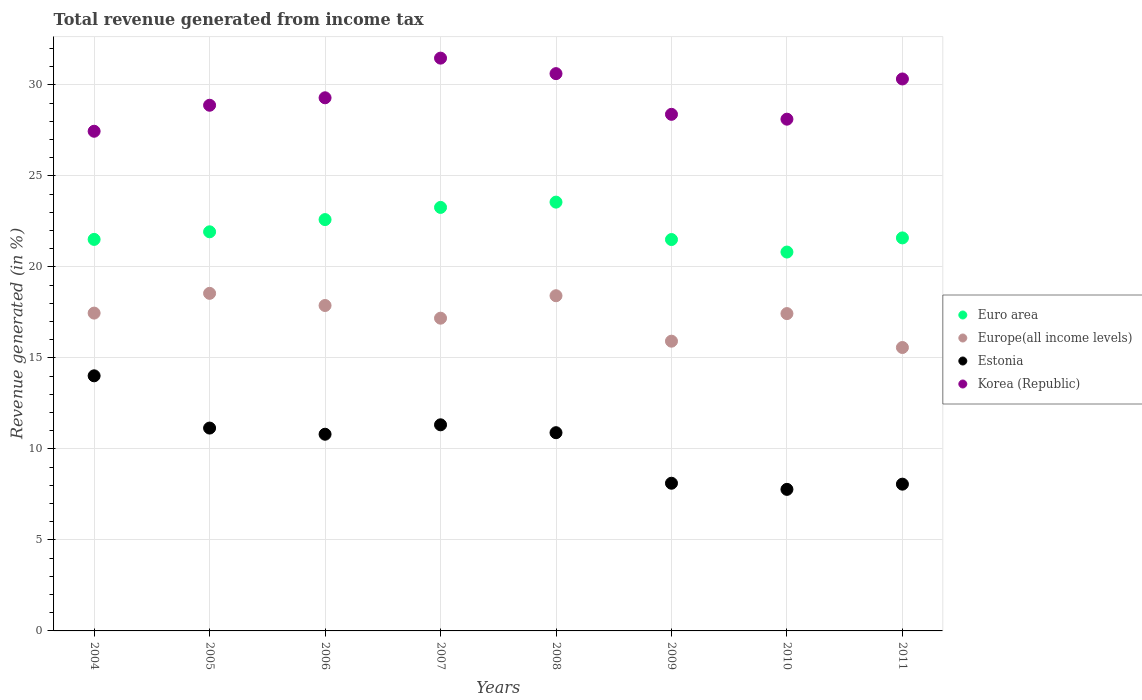How many different coloured dotlines are there?
Ensure brevity in your answer.  4. What is the total revenue generated in Europe(all income levels) in 2009?
Make the answer very short. 15.92. Across all years, what is the maximum total revenue generated in Euro area?
Provide a short and direct response. 23.56. Across all years, what is the minimum total revenue generated in Europe(all income levels)?
Your answer should be very brief. 15.57. What is the total total revenue generated in Euro area in the graph?
Give a very brief answer. 176.78. What is the difference between the total revenue generated in Europe(all income levels) in 2006 and that in 2009?
Offer a terse response. 1.96. What is the difference between the total revenue generated in Korea (Republic) in 2008 and the total revenue generated in Euro area in 2009?
Keep it short and to the point. 9.12. What is the average total revenue generated in Korea (Republic) per year?
Provide a succinct answer. 29.32. In the year 2010, what is the difference between the total revenue generated in Korea (Republic) and total revenue generated in Europe(all income levels)?
Provide a succinct answer. 10.68. What is the ratio of the total revenue generated in Korea (Republic) in 2004 to that in 2006?
Provide a short and direct response. 0.94. Is the difference between the total revenue generated in Korea (Republic) in 2004 and 2006 greater than the difference between the total revenue generated in Europe(all income levels) in 2004 and 2006?
Your answer should be compact. No. What is the difference between the highest and the second highest total revenue generated in Euro area?
Ensure brevity in your answer.  0.29. What is the difference between the highest and the lowest total revenue generated in Euro area?
Offer a very short reply. 2.74. Is it the case that in every year, the sum of the total revenue generated in Euro area and total revenue generated in Korea (Republic)  is greater than the sum of total revenue generated in Estonia and total revenue generated in Europe(all income levels)?
Provide a succinct answer. Yes. How many years are there in the graph?
Provide a short and direct response. 8. Are the values on the major ticks of Y-axis written in scientific E-notation?
Your response must be concise. No. How many legend labels are there?
Ensure brevity in your answer.  4. What is the title of the graph?
Make the answer very short. Total revenue generated from income tax. What is the label or title of the X-axis?
Your response must be concise. Years. What is the label or title of the Y-axis?
Keep it short and to the point. Revenue generated (in %). What is the Revenue generated (in %) in Euro area in 2004?
Offer a very short reply. 21.51. What is the Revenue generated (in %) in Europe(all income levels) in 2004?
Provide a succinct answer. 17.46. What is the Revenue generated (in %) of Estonia in 2004?
Provide a short and direct response. 14.02. What is the Revenue generated (in %) of Korea (Republic) in 2004?
Give a very brief answer. 27.45. What is the Revenue generated (in %) in Euro area in 2005?
Offer a very short reply. 21.93. What is the Revenue generated (in %) in Europe(all income levels) in 2005?
Give a very brief answer. 18.55. What is the Revenue generated (in %) in Estonia in 2005?
Your answer should be compact. 11.15. What is the Revenue generated (in %) in Korea (Republic) in 2005?
Ensure brevity in your answer.  28.88. What is the Revenue generated (in %) in Euro area in 2006?
Ensure brevity in your answer.  22.6. What is the Revenue generated (in %) in Europe(all income levels) in 2006?
Your response must be concise. 17.88. What is the Revenue generated (in %) of Estonia in 2006?
Your response must be concise. 10.81. What is the Revenue generated (in %) of Korea (Republic) in 2006?
Offer a terse response. 29.29. What is the Revenue generated (in %) of Euro area in 2007?
Offer a very short reply. 23.27. What is the Revenue generated (in %) in Europe(all income levels) in 2007?
Offer a very short reply. 17.18. What is the Revenue generated (in %) of Estonia in 2007?
Provide a short and direct response. 11.32. What is the Revenue generated (in %) in Korea (Republic) in 2007?
Ensure brevity in your answer.  31.47. What is the Revenue generated (in %) in Euro area in 2008?
Your answer should be very brief. 23.56. What is the Revenue generated (in %) of Europe(all income levels) in 2008?
Offer a very short reply. 18.42. What is the Revenue generated (in %) of Estonia in 2008?
Give a very brief answer. 10.89. What is the Revenue generated (in %) of Korea (Republic) in 2008?
Give a very brief answer. 30.62. What is the Revenue generated (in %) of Euro area in 2009?
Give a very brief answer. 21.5. What is the Revenue generated (in %) in Europe(all income levels) in 2009?
Give a very brief answer. 15.92. What is the Revenue generated (in %) of Estonia in 2009?
Make the answer very short. 8.11. What is the Revenue generated (in %) in Korea (Republic) in 2009?
Your response must be concise. 28.38. What is the Revenue generated (in %) in Euro area in 2010?
Your response must be concise. 20.82. What is the Revenue generated (in %) in Europe(all income levels) in 2010?
Your response must be concise. 17.44. What is the Revenue generated (in %) in Estonia in 2010?
Your response must be concise. 7.78. What is the Revenue generated (in %) in Korea (Republic) in 2010?
Give a very brief answer. 28.12. What is the Revenue generated (in %) in Euro area in 2011?
Make the answer very short. 21.59. What is the Revenue generated (in %) in Europe(all income levels) in 2011?
Keep it short and to the point. 15.57. What is the Revenue generated (in %) of Estonia in 2011?
Your answer should be compact. 8.06. What is the Revenue generated (in %) in Korea (Republic) in 2011?
Provide a succinct answer. 30.33. Across all years, what is the maximum Revenue generated (in %) in Euro area?
Offer a very short reply. 23.56. Across all years, what is the maximum Revenue generated (in %) in Europe(all income levels)?
Give a very brief answer. 18.55. Across all years, what is the maximum Revenue generated (in %) of Estonia?
Offer a very short reply. 14.02. Across all years, what is the maximum Revenue generated (in %) in Korea (Republic)?
Make the answer very short. 31.47. Across all years, what is the minimum Revenue generated (in %) in Euro area?
Provide a succinct answer. 20.82. Across all years, what is the minimum Revenue generated (in %) in Europe(all income levels)?
Offer a very short reply. 15.57. Across all years, what is the minimum Revenue generated (in %) of Estonia?
Your answer should be compact. 7.78. Across all years, what is the minimum Revenue generated (in %) of Korea (Republic)?
Your response must be concise. 27.45. What is the total Revenue generated (in %) of Euro area in the graph?
Offer a terse response. 176.78. What is the total Revenue generated (in %) of Europe(all income levels) in the graph?
Make the answer very short. 138.42. What is the total Revenue generated (in %) of Estonia in the graph?
Ensure brevity in your answer.  82.14. What is the total Revenue generated (in %) in Korea (Republic) in the graph?
Provide a succinct answer. 234.55. What is the difference between the Revenue generated (in %) of Euro area in 2004 and that in 2005?
Ensure brevity in your answer.  -0.42. What is the difference between the Revenue generated (in %) in Europe(all income levels) in 2004 and that in 2005?
Keep it short and to the point. -1.09. What is the difference between the Revenue generated (in %) of Estonia in 2004 and that in 2005?
Provide a short and direct response. 2.87. What is the difference between the Revenue generated (in %) in Korea (Republic) in 2004 and that in 2005?
Provide a short and direct response. -1.43. What is the difference between the Revenue generated (in %) of Euro area in 2004 and that in 2006?
Keep it short and to the point. -1.09. What is the difference between the Revenue generated (in %) of Europe(all income levels) in 2004 and that in 2006?
Keep it short and to the point. -0.42. What is the difference between the Revenue generated (in %) of Estonia in 2004 and that in 2006?
Your response must be concise. 3.21. What is the difference between the Revenue generated (in %) in Korea (Republic) in 2004 and that in 2006?
Your answer should be compact. -1.84. What is the difference between the Revenue generated (in %) in Euro area in 2004 and that in 2007?
Your answer should be very brief. -1.76. What is the difference between the Revenue generated (in %) in Europe(all income levels) in 2004 and that in 2007?
Provide a succinct answer. 0.28. What is the difference between the Revenue generated (in %) in Estonia in 2004 and that in 2007?
Provide a short and direct response. 2.69. What is the difference between the Revenue generated (in %) of Korea (Republic) in 2004 and that in 2007?
Ensure brevity in your answer.  -4.02. What is the difference between the Revenue generated (in %) in Euro area in 2004 and that in 2008?
Your answer should be compact. -2.05. What is the difference between the Revenue generated (in %) of Europe(all income levels) in 2004 and that in 2008?
Offer a terse response. -0.95. What is the difference between the Revenue generated (in %) in Estonia in 2004 and that in 2008?
Keep it short and to the point. 3.13. What is the difference between the Revenue generated (in %) of Korea (Republic) in 2004 and that in 2008?
Make the answer very short. -3.17. What is the difference between the Revenue generated (in %) in Euro area in 2004 and that in 2009?
Provide a succinct answer. 0.01. What is the difference between the Revenue generated (in %) in Europe(all income levels) in 2004 and that in 2009?
Give a very brief answer. 1.54. What is the difference between the Revenue generated (in %) of Estonia in 2004 and that in 2009?
Provide a short and direct response. 5.9. What is the difference between the Revenue generated (in %) in Korea (Republic) in 2004 and that in 2009?
Your answer should be very brief. -0.93. What is the difference between the Revenue generated (in %) in Euro area in 2004 and that in 2010?
Your answer should be compact. 0.69. What is the difference between the Revenue generated (in %) in Europe(all income levels) in 2004 and that in 2010?
Offer a very short reply. 0.03. What is the difference between the Revenue generated (in %) of Estonia in 2004 and that in 2010?
Your answer should be compact. 6.24. What is the difference between the Revenue generated (in %) of Korea (Republic) in 2004 and that in 2010?
Your answer should be compact. -0.66. What is the difference between the Revenue generated (in %) in Euro area in 2004 and that in 2011?
Ensure brevity in your answer.  -0.08. What is the difference between the Revenue generated (in %) of Europe(all income levels) in 2004 and that in 2011?
Your response must be concise. 1.89. What is the difference between the Revenue generated (in %) of Estonia in 2004 and that in 2011?
Your answer should be compact. 5.95. What is the difference between the Revenue generated (in %) in Korea (Republic) in 2004 and that in 2011?
Make the answer very short. -2.87. What is the difference between the Revenue generated (in %) of Euro area in 2005 and that in 2006?
Keep it short and to the point. -0.67. What is the difference between the Revenue generated (in %) in Europe(all income levels) in 2005 and that in 2006?
Offer a terse response. 0.67. What is the difference between the Revenue generated (in %) of Estonia in 2005 and that in 2006?
Your answer should be compact. 0.34. What is the difference between the Revenue generated (in %) of Korea (Republic) in 2005 and that in 2006?
Give a very brief answer. -0.41. What is the difference between the Revenue generated (in %) in Euro area in 2005 and that in 2007?
Your response must be concise. -1.34. What is the difference between the Revenue generated (in %) in Europe(all income levels) in 2005 and that in 2007?
Your response must be concise. 1.36. What is the difference between the Revenue generated (in %) of Estonia in 2005 and that in 2007?
Your answer should be compact. -0.18. What is the difference between the Revenue generated (in %) of Korea (Republic) in 2005 and that in 2007?
Keep it short and to the point. -2.59. What is the difference between the Revenue generated (in %) of Euro area in 2005 and that in 2008?
Provide a succinct answer. -1.63. What is the difference between the Revenue generated (in %) of Europe(all income levels) in 2005 and that in 2008?
Provide a succinct answer. 0.13. What is the difference between the Revenue generated (in %) of Estonia in 2005 and that in 2008?
Offer a very short reply. 0.25. What is the difference between the Revenue generated (in %) in Korea (Republic) in 2005 and that in 2008?
Offer a very short reply. -1.74. What is the difference between the Revenue generated (in %) of Euro area in 2005 and that in 2009?
Give a very brief answer. 0.42. What is the difference between the Revenue generated (in %) in Europe(all income levels) in 2005 and that in 2009?
Give a very brief answer. 2.63. What is the difference between the Revenue generated (in %) in Estonia in 2005 and that in 2009?
Provide a short and direct response. 3.03. What is the difference between the Revenue generated (in %) in Korea (Republic) in 2005 and that in 2009?
Give a very brief answer. 0.5. What is the difference between the Revenue generated (in %) in Euro area in 2005 and that in 2010?
Ensure brevity in your answer.  1.11. What is the difference between the Revenue generated (in %) in Europe(all income levels) in 2005 and that in 2010?
Offer a very short reply. 1.11. What is the difference between the Revenue generated (in %) of Estonia in 2005 and that in 2010?
Your answer should be compact. 3.37. What is the difference between the Revenue generated (in %) of Korea (Republic) in 2005 and that in 2010?
Offer a very short reply. 0.77. What is the difference between the Revenue generated (in %) of Euro area in 2005 and that in 2011?
Your answer should be very brief. 0.33. What is the difference between the Revenue generated (in %) of Europe(all income levels) in 2005 and that in 2011?
Give a very brief answer. 2.98. What is the difference between the Revenue generated (in %) in Estonia in 2005 and that in 2011?
Your answer should be compact. 3.08. What is the difference between the Revenue generated (in %) of Korea (Republic) in 2005 and that in 2011?
Offer a very short reply. -1.44. What is the difference between the Revenue generated (in %) of Euro area in 2006 and that in 2007?
Offer a very short reply. -0.67. What is the difference between the Revenue generated (in %) in Europe(all income levels) in 2006 and that in 2007?
Your answer should be very brief. 0.7. What is the difference between the Revenue generated (in %) in Estonia in 2006 and that in 2007?
Give a very brief answer. -0.52. What is the difference between the Revenue generated (in %) in Korea (Republic) in 2006 and that in 2007?
Make the answer very short. -2.18. What is the difference between the Revenue generated (in %) of Euro area in 2006 and that in 2008?
Offer a terse response. -0.96. What is the difference between the Revenue generated (in %) of Europe(all income levels) in 2006 and that in 2008?
Keep it short and to the point. -0.54. What is the difference between the Revenue generated (in %) in Estonia in 2006 and that in 2008?
Offer a terse response. -0.08. What is the difference between the Revenue generated (in %) in Korea (Republic) in 2006 and that in 2008?
Provide a short and direct response. -1.33. What is the difference between the Revenue generated (in %) of Euro area in 2006 and that in 2009?
Ensure brevity in your answer.  1.1. What is the difference between the Revenue generated (in %) in Europe(all income levels) in 2006 and that in 2009?
Your response must be concise. 1.96. What is the difference between the Revenue generated (in %) in Estonia in 2006 and that in 2009?
Your answer should be compact. 2.69. What is the difference between the Revenue generated (in %) in Korea (Republic) in 2006 and that in 2009?
Offer a terse response. 0.91. What is the difference between the Revenue generated (in %) of Euro area in 2006 and that in 2010?
Offer a very short reply. 1.78. What is the difference between the Revenue generated (in %) of Europe(all income levels) in 2006 and that in 2010?
Make the answer very short. 0.44. What is the difference between the Revenue generated (in %) in Estonia in 2006 and that in 2010?
Give a very brief answer. 3.03. What is the difference between the Revenue generated (in %) of Korea (Republic) in 2006 and that in 2010?
Provide a succinct answer. 1.17. What is the difference between the Revenue generated (in %) in Euro area in 2006 and that in 2011?
Your answer should be compact. 1.01. What is the difference between the Revenue generated (in %) in Europe(all income levels) in 2006 and that in 2011?
Offer a terse response. 2.31. What is the difference between the Revenue generated (in %) in Estonia in 2006 and that in 2011?
Make the answer very short. 2.74. What is the difference between the Revenue generated (in %) of Korea (Republic) in 2006 and that in 2011?
Offer a terse response. -1.03. What is the difference between the Revenue generated (in %) in Euro area in 2007 and that in 2008?
Keep it short and to the point. -0.29. What is the difference between the Revenue generated (in %) in Europe(all income levels) in 2007 and that in 2008?
Provide a succinct answer. -1.23. What is the difference between the Revenue generated (in %) in Estonia in 2007 and that in 2008?
Your answer should be compact. 0.43. What is the difference between the Revenue generated (in %) of Korea (Republic) in 2007 and that in 2008?
Your answer should be very brief. 0.85. What is the difference between the Revenue generated (in %) in Euro area in 2007 and that in 2009?
Your response must be concise. 1.77. What is the difference between the Revenue generated (in %) of Europe(all income levels) in 2007 and that in 2009?
Keep it short and to the point. 1.26. What is the difference between the Revenue generated (in %) of Estonia in 2007 and that in 2009?
Provide a succinct answer. 3.21. What is the difference between the Revenue generated (in %) of Korea (Republic) in 2007 and that in 2009?
Provide a short and direct response. 3.09. What is the difference between the Revenue generated (in %) in Euro area in 2007 and that in 2010?
Your answer should be very brief. 2.45. What is the difference between the Revenue generated (in %) of Europe(all income levels) in 2007 and that in 2010?
Your response must be concise. -0.25. What is the difference between the Revenue generated (in %) in Estonia in 2007 and that in 2010?
Offer a terse response. 3.55. What is the difference between the Revenue generated (in %) of Korea (Republic) in 2007 and that in 2010?
Your answer should be very brief. 3.35. What is the difference between the Revenue generated (in %) of Euro area in 2007 and that in 2011?
Provide a short and direct response. 1.68. What is the difference between the Revenue generated (in %) of Europe(all income levels) in 2007 and that in 2011?
Provide a succinct answer. 1.61. What is the difference between the Revenue generated (in %) of Estonia in 2007 and that in 2011?
Your answer should be compact. 3.26. What is the difference between the Revenue generated (in %) in Korea (Republic) in 2007 and that in 2011?
Provide a short and direct response. 1.14. What is the difference between the Revenue generated (in %) in Euro area in 2008 and that in 2009?
Your answer should be very brief. 2.06. What is the difference between the Revenue generated (in %) of Europe(all income levels) in 2008 and that in 2009?
Your answer should be very brief. 2.5. What is the difference between the Revenue generated (in %) in Estonia in 2008 and that in 2009?
Your answer should be compact. 2.78. What is the difference between the Revenue generated (in %) in Korea (Republic) in 2008 and that in 2009?
Provide a succinct answer. 2.24. What is the difference between the Revenue generated (in %) of Euro area in 2008 and that in 2010?
Give a very brief answer. 2.74. What is the difference between the Revenue generated (in %) in Europe(all income levels) in 2008 and that in 2010?
Provide a short and direct response. 0.98. What is the difference between the Revenue generated (in %) of Estonia in 2008 and that in 2010?
Provide a short and direct response. 3.11. What is the difference between the Revenue generated (in %) of Korea (Republic) in 2008 and that in 2010?
Ensure brevity in your answer.  2.5. What is the difference between the Revenue generated (in %) of Euro area in 2008 and that in 2011?
Give a very brief answer. 1.97. What is the difference between the Revenue generated (in %) in Europe(all income levels) in 2008 and that in 2011?
Offer a very short reply. 2.84. What is the difference between the Revenue generated (in %) of Estonia in 2008 and that in 2011?
Offer a terse response. 2.83. What is the difference between the Revenue generated (in %) in Korea (Republic) in 2008 and that in 2011?
Provide a succinct answer. 0.29. What is the difference between the Revenue generated (in %) in Euro area in 2009 and that in 2010?
Provide a succinct answer. 0.69. What is the difference between the Revenue generated (in %) in Europe(all income levels) in 2009 and that in 2010?
Provide a succinct answer. -1.52. What is the difference between the Revenue generated (in %) of Estonia in 2009 and that in 2010?
Keep it short and to the point. 0.34. What is the difference between the Revenue generated (in %) in Korea (Republic) in 2009 and that in 2010?
Your answer should be compact. 0.27. What is the difference between the Revenue generated (in %) in Euro area in 2009 and that in 2011?
Give a very brief answer. -0.09. What is the difference between the Revenue generated (in %) of Europe(all income levels) in 2009 and that in 2011?
Provide a succinct answer. 0.35. What is the difference between the Revenue generated (in %) in Estonia in 2009 and that in 2011?
Give a very brief answer. 0.05. What is the difference between the Revenue generated (in %) of Korea (Republic) in 2009 and that in 2011?
Give a very brief answer. -1.94. What is the difference between the Revenue generated (in %) of Euro area in 2010 and that in 2011?
Your answer should be compact. -0.78. What is the difference between the Revenue generated (in %) in Europe(all income levels) in 2010 and that in 2011?
Your answer should be very brief. 1.86. What is the difference between the Revenue generated (in %) in Estonia in 2010 and that in 2011?
Keep it short and to the point. -0.29. What is the difference between the Revenue generated (in %) in Korea (Republic) in 2010 and that in 2011?
Your response must be concise. -2.21. What is the difference between the Revenue generated (in %) in Euro area in 2004 and the Revenue generated (in %) in Europe(all income levels) in 2005?
Give a very brief answer. 2.96. What is the difference between the Revenue generated (in %) of Euro area in 2004 and the Revenue generated (in %) of Estonia in 2005?
Offer a terse response. 10.37. What is the difference between the Revenue generated (in %) in Euro area in 2004 and the Revenue generated (in %) in Korea (Republic) in 2005?
Offer a very short reply. -7.37. What is the difference between the Revenue generated (in %) of Europe(all income levels) in 2004 and the Revenue generated (in %) of Estonia in 2005?
Your answer should be very brief. 6.32. What is the difference between the Revenue generated (in %) of Europe(all income levels) in 2004 and the Revenue generated (in %) of Korea (Republic) in 2005?
Keep it short and to the point. -11.42. What is the difference between the Revenue generated (in %) in Estonia in 2004 and the Revenue generated (in %) in Korea (Republic) in 2005?
Your response must be concise. -14.87. What is the difference between the Revenue generated (in %) of Euro area in 2004 and the Revenue generated (in %) of Europe(all income levels) in 2006?
Ensure brevity in your answer.  3.63. What is the difference between the Revenue generated (in %) in Euro area in 2004 and the Revenue generated (in %) in Estonia in 2006?
Provide a succinct answer. 10.7. What is the difference between the Revenue generated (in %) in Euro area in 2004 and the Revenue generated (in %) in Korea (Republic) in 2006?
Your answer should be very brief. -7.78. What is the difference between the Revenue generated (in %) of Europe(all income levels) in 2004 and the Revenue generated (in %) of Estonia in 2006?
Your answer should be compact. 6.66. What is the difference between the Revenue generated (in %) in Europe(all income levels) in 2004 and the Revenue generated (in %) in Korea (Republic) in 2006?
Provide a succinct answer. -11.83. What is the difference between the Revenue generated (in %) in Estonia in 2004 and the Revenue generated (in %) in Korea (Republic) in 2006?
Give a very brief answer. -15.28. What is the difference between the Revenue generated (in %) in Euro area in 2004 and the Revenue generated (in %) in Europe(all income levels) in 2007?
Your answer should be compact. 4.33. What is the difference between the Revenue generated (in %) of Euro area in 2004 and the Revenue generated (in %) of Estonia in 2007?
Offer a very short reply. 10.19. What is the difference between the Revenue generated (in %) in Euro area in 2004 and the Revenue generated (in %) in Korea (Republic) in 2007?
Make the answer very short. -9.96. What is the difference between the Revenue generated (in %) in Europe(all income levels) in 2004 and the Revenue generated (in %) in Estonia in 2007?
Provide a succinct answer. 6.14. What is the difference between the Revenue generated (in %) in Europe(all income levels) in 2004 and the Revenue generated (in %) in Korea (Republic) in 2007?
Offer a very short reply. -14.01. What is the difference between the Revenue generated (in %) in Estonia in 2004 and the Revenue generated (in %) in Korea (Republic) in 2007?
Your answer should be compact. -17.45. What is the difference between the Revenue generated (in %) in Euro area in 2004 and the Revenue generated (in %) in Europe(all income levels) in 2008?
Ensure brevity in your answer.  3.1. What is the difference between the Revenue generated (in %) of Euro area in 2004 and the Revenue generated (in %) of Estonia in 2008?
Your response must be concise. 10.62. What is the difference between the Revenue generated (in %) of Euro area in 2004 and the Revenue generated (in %) of Korea (Republic) in 2008?
Keep it short and to the point. -9.11. What is the difference between the Revenue generated (in %) in Europe(all income levels) in 2004 and the Revenue generated (in %) in Estonia in 2008?
Ensure brevity in your answer.  6.57. What is the difference between the Revenue generated (in %) in Europe(all income levels) in 2004 and the Revenue generated (in %) in Korea (Republic) in 2008?
Your response must be concise. -13.16. What is the difference between the Revenue generated (in %) in Estonia in 2004 and the Revenue generated (in %) in Korea (Republic) in 2008?
Offer a very short reply. -16.6. What is the difference between the Revenue generated (in %) in Euro area in 2004 and the Revenue generated (in %) in Europe(all income levels) in 2009?
Provide a short and direct response. 5.59. What is the difference between the Revenue generated (in %) in Euro area in 2004 and the Revenue generated (in %) in Estonia in 2009?
Ensure brevity in your answer.  13.4. What is the difference between the Revenue generated (in %) of Euro area in 2004 and the Revenue generated (in %) of Korea (Republic) in 2009?
Offer a terse response. -6.87. What is the difference between the Revenue generated (in %) of Europe(all income levels) in 2004 and the Revenue generated (in %) of Estonia in 2009?
Your response must be concise. 9.35. What is the difference between the Revenue generated (in %) in Europe(all income levels) in 2004 and the Revenue generated (in %) in Korea (Republic) in 2009?
Keep it short and to the point. -10.92. What is the difference between the Revenue generated (in %) of Estonia in 2004 and the Revenue generated (in %) of Korea (Republic) in 2009?
Give a very brief answer. -14.37. What is the difference between the Revenue generated (in %) in Euro area in 2004 and the Revenue generated (in %) in Europe(all income levels) in 2010?
Offer a very short reply. 4.08. What is the difference between the Revenue generated (in %) in Euro area in 2004 and the Revenue generated (in %) in Estonia in 2010?
Offer a terse response. 13.73. What is the difference between the Revenue generated (in %) of Euro area in 2004 and the Revenue generated (in %) of Korea (Republic) in 2010?
Ensure brevity in your answer.  -6.61. What is the difference between the Revenue generated (in %) in Europe(all income levels) in 2004 and the Revenue generated (in %) in Estonia in 2010?
Offer a very short reply. 9.68. What is the difference between the Revenue generated (in %) of Europe(all income levels) in 2004 and the Revenue generated (in %) of Korea (Republic) in 2010?
Provide a succinct answer. -10.65. What is the difference between the Revenue generated (in %) in Estonia in 2004 and the Revenue generated (in %) in Korea (Republic) in 2010?
Your answer should be very brief. -14.1. What is the difference between the Revenue generated (in %) of Euro area in 2004 and the Revenue generated (in %) of Europe(all income levels) in 2011?
Your response must be concise. 5.94. What is the difference between the Revenue generated (in %) in Euro area in 2004 and the Revenue generated (in %) in Estonia in 2011?
Your answer should be very brief. 13.45. What is the difference between the Revenue generated (in %) of Euro area in 2004 and the Revenue generated (in %) of Korea (Republic) in 2011?
Offer a very short reply. -8.82. What is the difference between the Revenue generated (in %) in Europe(all income levels) in 2004 and the Revenue generated (in %) in Estonia in 2011?
Your response must be concise. 9.4. What is the difference between the Revenue generated (in %) of Europe(all income levels) in 2004 and the Revenue generated (in %) of Korea (Republic) in 2011?
Your answer should be compact. -12.86. What is the difference between the Revenue generated (in %) of Estonia in 2004 and the Revenue generated (in %) of Korea (Republic) in 2011?
Keep it short and to the point. -16.31. What is the difference between the Revenue generated (in %) in Euro area in 2005 and the Revenue generated (in %) in Europe(all income levels) in 2006?
Keep it short and to the point. 4.05. What is the difference between the Revenue generated (in %) in Euro area in 2005 and the Revenue generated (in %) in Estonia in 2006?
Offer a terse response. 11.12. What is the difference between the Revenue generated (in %) of Euro area in 2005 and the Revenue generated (in %) of Korea (Republic) in 2006?
Offer a very short reply. -7.36. What is the difference between the Revenue generated (in %) of Europe(all income levels) in 2005 and the Revenue generated (in %) of Estonia in 2006?
Keep it short and to the point. 7.74. What is the difference between the Revenue generated (in %) of Europe(all income levels) in 2005 and the Revenue generated (in %) of Korea (Republic) in 2006?
Your answer should be very brief. -10.74. What is the difference between the Revenue generated (in %) in Estonia in 2005 and the Revenue generated (in %) in Korea (Republic) in 2006?
Offer a very short reply. -18.15. What is the difference between the Revenue generated (in %) of Euro area in 2005 and the Revenue generated (in %) of Europe(all income levels) in 2007?
Provide a succinct answer. 4.75. What is the difference between the Revenue generated (in %) of Euro area in 2005 and the Revenue generated (in %) of Estonia in 2007?
Ensure brevity in your answer.  10.6. What is the difference between the Revenue generated (in %) of Euro area in 2005 and the Revenue generated (in %) of Korea (Republic) in 2007?
Provide a succinct answer. -9.54. What is the difference between the Revenue generated (in %) of Europe(all income levels) in 2005 and the Revenue generated (in %) of Estonia in 2007?
Provide a succinct answer. 7.22. What is the difference between the Revenue generated (in %) in Europe(all income levels) in 2005 and the Revenue generated (in %) in Korea (Republic) in 2007?
Your response must be concise. -12.92. What is the difference between the Revenue generated (in %) in Estonia in 2005 and the Revenue generated (in %) in Korea (Republic) in 2007?
Provide a succinct answer. -20.33. What is the difference between the Revenue generated (in %) of Euro area in 2005 and the Revenue generated (in %) of Europe(all income levels) in 2008?
Your response must be concise. 3.51. What is the difference between the Revenue generated (in %) of Euro area in 2005 and the Revenue generated (in %) of Estonia in 2008?
Offer a very short reply. 11.04. What is the difference between the Revenue generated (in %) in Euro area in 2005 and the Revenue generated (in %) in Korea (Republic) in 2008?
Keep it short and to the point. -8.69. What is the difference between the Revenue generated (in %) of Europe(all income levels) in 2005 and the Revenue generated (in %) of Estonia in 2008?
Keep it short and to the point. 7.66. What is the difference between the Revenue generated (in %) in Europe(all income levels) in 2005 and the Revenue generated (in %) in Korea (Republic) in 2008?
Your response must be concise. -12.07. What is the difference between the Revenue generated (in %) of Estonia in 2005 and the Revenue generated (in %) of Korea (Republic) in 2008?
Provide a succinct answer. -19.47. What is the difference between the Revenue generated (in %) in Euro area in 2005 and the Revenue generated (in %) in Europe(all income levels) in 2009?
Give a very brief answer. 6.01. What is the difference between the Revenue generated (in %) of Euro area in 2005 and the Revenue generated (in %) of Estonia in 2009?
Your response must be concise. 13.81. What is the difference between the Revenue generated (in %) in Euro area in 2005 and the Revenue generated (in %) in Korea (Republic) in 2009?
Your response must be concise. -6.45. What is the difference between the Revenue generated (in %) in Europe(all income levels) in 2005 and the Revenue generated (in %) in Estonia in 2009?
Provide a succinct answer. 10.43. What is the difference between the Revenue generated (in %) in Europe(all income levels) in 2005 and the Revenue generated (in %) in Korea (Republic) in 2009?
Provide a succinct answer. -9.84. What is the difference between the Revenue generated (in %) of Estonia in 2005 and the Revenue generated (in %) of Korea (Republic) in 2009?
Ensure brevity in your answer.  -17.24. What is the difference between the Revenue generated (in %) of Euro area in 2005 and the Revenue generated (in %) of Europe(all income levels) in 2010?
Provide a succinct answer. 4.49. What is the difference between the Revenue generated (in %) in Euro area in 2005 and the Revenue generated (in %) in Estonia in 2010?
Keep it short and to the point. 14.15. What is the difference between the Revenue generated (in %) of Euro area in 2005 and the Revenue generated (in %) of Korea (Republic) in 2010?
Ensure brevity in your answer.  -6.19. What is the difference between the Revenue generated (in %) in Europe(all income levels) in 2005 and the Revenue generated (in %) in Estonia in 2010?
Make the answer very short. 10.77. What is the difference between the Revenue generated (in %) in Europe(all income levels) in 2005 and the Revenue generated (in %) in Korea (Republic) in 2010?
Your response must be concise. -9.57. What is the difference between the Revenue generated (in %) in Estonia in 2005 and the Revenue generated (in %) in Korea (Republic) in 2010?
Offer a very short reply. -16.97. What is the difference between the Revenue generated (in %) of Euro area in 2005 and the Revenue generated (in %) of Europe(all income levels) in 2011?
Provide a succinct answer. 6.36. What is the difference between the Revenue generated (in %) of Euro area in 2005 and the Revenue generated (in %) of Estonia in 2011?
Your response must be concise. 13.86. What is the difference between the Revenue generated (in %) of Euro area in 2005 and the Revenue generated (in %) of Korea (Republic) in 2011?
Keep it short and to the point. -8.4. What is the difference between the Revenue generated (in %) in Europe(all income levels) in 2005 and the Revenue generated (in %) in Estonia in 2011?
Make the answer very short. 10.48. What is the difference between the Revenue generated (in %) of Europe(all income levels) in 2005 and the Revenue generated (in %) of Korea (Republic) in 2011?
Make the answer very short. -11.78. What is the difference between the Revenue generated (in %) in Estonia in 2005 and the Revenue generated (in %) in Korea (Republic) in 2011?
Keep it short and to the point. -19.18. What is the difference between the Revenue generated (in %) of Euro area in 2006 and the Revenue generated (in %) of Europe(all income levels) in 2007?
Your response must be concise. 5.42. What is the difference between the Revenue generated (in %) in Euro area in 2006 and the Revenue generated (in %) in Estonia in 2007?
Make the answer very short. 11.28. What is the difference between the Revenue generated (in %) in Euro area in 2006 and the Revenue generated (in %) in Korea (Republic) in 2007?
Offer a very short reply. -8.87. What is the difference between the Revenue generated (in %) in Europe(all income levels) in 2006 and the Revenue generated (in %) in Estonia in 2007?
Provide a succinct answer. 6.56. What is the difference between the Revenue generated (in %) of Europe(all income levels) in 2006 and the Revenue generated (in %) of Korea (Republic) in 2007?
Provide a short and direct response. -13.59. What is the difference between the Revenue generated (in %) in Estonia in 2006 and the Revenue generated (in %) in Korea (Republic) in 2007?
Your answer should be compact. -20.66. What is the difference between the Revenue generated (in %) in Euro area in 2006 and the Revenue generated (in %) in Europe(all income levels) in 2008?
Give a very brief answer. 4.18. What is the difference between the Revenue generated (in %) of Euro area in 2006 and the Revenue generated (in %) of Estonia in 2008?
Ensure brevity in your answer.  11.71. What is the difference between the Revenue generated (in %) in Euro area in 2006 and the Revenue generated (in %) in Korea (Republic) in 2008?
Ensure brevity in your answer.  -8.02. What is the difference between the Revenue generated (in %) in Europe(all income levels) in 2006 and the Revenue generated (in %) in Estonia in 2008?
Offer a terse response. 6.99. What is the difference between the Revenue generated (in %) in Europe(all income levels) in 2006 and the Revenue generated (in %) in Korea (Republic) in 2008?
Give a very brief answer. -12.74. What is the difference between the Revenue generated (in %) of Estonia in 2006 and the Revenue generated (in %) of Korea (Republic) in 2008?
Ensure brevity in your answer.  -19.81. What is the difference between the Revenue generated (in %) in Euro area in 2006 and the Revenue generated (in %) in Europe(all income levels) in 2009?
Ensure brevity in your answer.  6.68. What is the difference between the Revenue generated (in %) in Euro area in 2006 and the Revenue generated (in %) in Estonia in 2009?
Make the answer very short. 14.49. What is the difference between the Revenue generated (in %) in Euro area in 2006 and the Revenue generated (in %) in Korea (Republic) in 2009?
Your response must be concise. -5.78. What is the difference between the Revenue generated (in %) in Europe(all income levels) in 2006 and the Revenue generated (in %) in Estonia in 2009?
Offer a very short reply. 9.77. What is the difference between the Revenue generated (in %) of Europe(all income levels) in 2006 and the Revenue generated (in %) of Korea (Republic) in 2009?
Give a very brief answer. -10.5. What is the difference between the Revenue generated (in %) in Estonia in 2006 and the Revenue generated (in %) in Korea (Republic) in 2009?
Your answer should be very brief. -17.58. What is the difference between the Revenue generated (in %) of Euro area in 2006 and the Revenue generated (in %) of Europe(all income levels) in 2010?
Give a very brief answer. 5.16. What is the difference between the Revenue generated (in %) in Euro area in 2006 and the Revenue generated (in %) in Estonia in 2010?
Your answer should be compact. 14.82. What is the difference between the Revenue generated (in %) of Euro area in 2006 and the Revenue generated (in %) of Korea (Republic) in 2010?
Your response must be concise. -5.52. What is the difference between the Revenue generated (in %) in Europe(all income levels) in 2006 and the Revenue generated (in %) in Estonia in 2010?
Your answer should be very brief. 10.1. What is the difference between the Revenue generated (in %) of Europe(all income levels) in 2006 and the Revenue generated (in %) of Korea (Republic) in 2010?
Offer a very short reply. -10.24. What is the difference between the Revenue generated (in %) of Estonia in 2006 and the Revenue generated (in %) of Korea (Republic) in 2010?
Keep it short and to the point. -17.31. What is the difference between the Revenue generated (in %) in Euro area in 2006 and the Revenue generated (in %) in Europe(all income levels) in 2011?
Make the answer very short. 7.03. What is the difference between the Revenue generated (in %) of Euro area in 2006 and the Revenue generated (in %) of Estonia in 2011?
Provide a succinct answer. 14.54. What is the difference between the Revenue generated (in %) of Euro area in 2006 and the Revenue generated (in %) of Korea (Republic) in 2011?
Provide a succinct answer. -7.73. What is the difference between the Revenue generated (in %) of Europe(all income levels) in 2006 and the Revenue generated (in %) of Estonia in 2011?
Offer a very short reply. 9.82. What is the difference between the Revenue generated (in %) in Europe(all income levels) in 2006 and the Revenue generated (in %) in Korea (Republic) in 2011?
Offer a very short reply. -12.45. What is the difference between the Revenue generated (in %) of Estonia in 2006 and the Revenue generated (in %) of Korea (Republic) in 2011?
Your answer should be compact. -19.52. What is the difference between the Revenue generated (in %) in Euro area in 2007 and the Revenue generated (in %) in Europe(all income levels) in 2008?
Your response must be concise. 4.85. What is the difference between the Revenue generated (in %) in Euro area in 2007 and the Revenue generated (in %) in Estonia in 2008?
Provide a short and direct response. 12.38. What is the difference between the Revenue generated (in %) in Euro area in 2007 and the Revenue generated (in %) in Korea (Republic) in 2008?
Give a very brief answer. -7.35. What is the difference between the Revenue generated (in %) of Europe(all income levels) in 2007 and the Revenue generated (in %) of Estonia in 2008?
Offer a very short reply. 6.29. What is the difference between the Revenue generated (in %) of Europe(all income levels) in 2007 and the Revenue generated (in %) of Korea (Republic) in 2008?
Give a very brief answer. -13.44. What is the difference between the Revenue generated (in %) in Estonia in 2007 and the Revenue generated (in %) in Korea (Republic) in 2008?
Provide a short and direct response. -19.29. What is the difference between the Revenue generated (in %) of Euro area in 2007 and the Revenue generated (in %) of Europe(all income levels) in 2009?
Offer a very short reply. 7.35. What is the difference between the Revenue generated (in %) in Euro area in 2007 and the Revenue generated (in %) in Estonia in 2009?
Offer a very short reply. 15.15. What is the difference between the Revenue generated (in %) in Euro area in 2007 and the Revenue generated (in %) in Korea (Republic) in 2009?
Your answer should be very brief. -5.11. What is the difference between the Revenue generated (in %) in Europe(all income levels) in 2007 and the Revenue generated (in %) in Estonia in 2009?
Your answer should be compact. 9.07. What is the difference between the Revenue generated (in %) of Europe(all income levels) in 2007 and the Revenue generated (in %) of Korea (Republic) in 2009?
Ensure brevity in your answer.  -11.2. What is the difference between the Revenue generated (in %) of Estonia in 2007 and the Revenue generated (in %) of Korea (Republic) in 2009?
Provide a short and direct response. -17.06. What is the difference between the Revenue generated (in %) of Euro area in 2007 and the Revenue generated (in %) of Europe(all income levels) in 2010?
Your answer should be compact. 5.83. What is the difference between the Revenue generated (in %) in Euro area in 2007 and the Revenue generated (in %) in Estonia in 2010?
Give a very brief answer. 15.49. What is the difference between the Revenue generated (in %) in Euro area in 2007 and the Revenue generated (in %) in Korea (Republic) in 2010?
Provide a short and direct response. -4.85. What is the difference between the Revenue generated (in %) of Europe(all income levels) in 2007 and the Revenue generated (in %) of Estonia in 2010?
Make the answer very short. 9.41. What is the difference between the Revenue generated (in %) in Europe(all income levels) in 2007 and the Revenue generated (in %) in Korea (Republic) in 2010?
Offer a very short reply. -10.93. What is the difference between the Revenue generated (in %) in Estonia in 2007 and the Revenue generated (in %) in Korea (Republic) in 2010?
Provide a succinct answer. -16.79. What is the difference between the Revenue generated (in %) of Euro area in 2007 and the Revenue generated (in %) of Europe(all income levels) in 2011?
Your answer should be very brief. 7.7. What is the difference between the Revenue generated (in %) of Euro area in 2007 and the Revenue generated (in %) of Estonia in 2011?
Offer a very short reply. 15.21. What is the difference between the Revenue generated (in %) of Euro area in 2007 and the Revenue generated (in %) of Korea (Republic) in 2011?
Your answer should be very brief. -7.06. What is the difference between the Revenue generated (in %) in Europe(all income levels) in 2007 and the Revenue generated (in %) in Estonia in 2011?
Provide a succinct answer. 9.12. What is the difference between the Revenue generated (in %) in Europe(all income levels) in 2007 and the Revenue generated (in %) in Korea (Republic) in 2011?
Provide a short and direct response. -13.14. What is the difference between the Revenue generated (in %) in Estonia in 2007 and the Revenue generated (in %) in Korea (Republic) in 2011?
Provide a short and direct response. -19. What is the difference between the Revenue generated (in %) of Euro area in 2008 and the Revenue generated (in %) of Europe(all income levels) in 2009?
Keep it short and to the point. 7.64. What is the difference between the Revenue generated (in %) of Euro area in 2008 and the Revenue generated (in %) of Estonia in 2009?
Your response must be concise. 15.45. What is the difference between the Revenue generated (in %) of Euro area in 2008 and the Revenue generated (in %) of Korea (Republic) in 2009?
Your answer should be compact. -4.82. What is the difference between the Revenue generated (in %) in Europe(all income levels) in 2008 and the Revenue generated (in %) in Estonia in 2009?
Your answer should be very brief. 10.3. What is the difference between the Revenue generated (in %) in Europe(all income levels) in 2008 and the Revenue generated (in %) in Korea (Republic) in 2009?
Give a very brief answer. -9.97. What is the difference between the Revenue generated (in %) in Estonia in 2008 and the Revenue generated (in %) in Korea (Republic) in 2009?
Provide a short and direct response. -17.49. What is the difference between the Revenue generated (in %) of Euro area in 2008 and the Revenue generated (in %) of Europe(all income levels) in 2010?
Your answer should be compact. 6.12. What is the difference between the Revenue generated (in %) in Euro area in 2008 and the Revenue generated (in %) in Estonia in 2010?
Provide a short and direct response. 15.78. What is the difference between the Revenue generated (in %) of Euro area in 2008 and the Revenue generated (in %) of Korea (Republic) in 2010?
Your answer should be compact. -4.56. What is the difference between the Revenue generated (in %) in Europe(all income levels) in 2008 and the Revenue generated (in %) in Estonia in 2010?
Provide a short and direct response. 10.64. What is the difference between the Revenue generated (in %) of Europe(all income levels) in 2008 and the Revenue generated (in %) of Korea (Republic) in 2010?
Offer a very short reply. -9.7. What is the difference between the Revenue generated (in %) of Estonia in 2008 and the Revenue generated (in %) of Korea (Republic) in 2010?
Offer a very short reply. -17.23. What is the difference between the Revenue generated (in %) in Euro area in 2008 and the Revenue generated (in %) in Europe(all income levels) in 2011?
Your answer should be very brief. 7.99. What is the difference between the Revenue generated (in %) of Euro area in 2008 and the Revenue generated (in %) of Estonia in 2011?
Make the answer very short. 15.5. What is the difference between the Revenue generated (in %) of Euro area in 2008 and the Revenue generated (in %) of Korea (Republic) in 2011?
Your response must be concise. -6.77. What is the difference between the Revenue generated (in %) in Europe(all income levels) in 2008 and the Revenue generated (in %) in Estonia in 2011?
Provide a short and direct response. 10.35. What is the difference between the Revenue generated (in %) in Europe(all income levels) in 2008 and the Revenue generated (in %) in Korea (Republic) in 2011?
Provide a succinct answer. -11.91. What is the difference between the Revenue generated (in %) in Estonia in 2008 and the Revenue generated (in %) in Korea (Republic) in 2011?
Ensure brevity in your answer.  -19.44. What is the difference between the Revenue generated (in %) in Euro area in 2009 and the Revenue generated (in %) in Europe(all income levels) in 2010?
Provide a succinct answer. 4.07. What is the difference between the Revenue generated (in %) of Euro area in 2009 and the Revenue generated (in %) of Estonia in 2010?
Offer a very short reply. 13.73. What is the difference between the Revenue generated (in %) in Euro area in 2009 and the Revenue generated (in %) in Korea (Republic) in 2010?
Offer a terse response. -6.61. What is the difference between the Revenue generated (in %) in Europe(all income levels) in 2009 and the Revenue generated (in %) in Estonia in 2010?
Offer a terse response. 8.14. What is the difference between the Revenue generated (in %) in Europe(all income levels) in 2009 and the Revenue generated (in %) in Korea (Republic) in 2010?
Make the answer very short. -12.2. What is the difference between the Revenue generated (in %) of Estonia in 2009 and the Revenue generated (in %) of Korea (Republic) in 2010?
Your answer should be very brief. -20. What is the difference between the Revenue generated (in %) in Euro area in 2009 and the Revenue generated (in %) in Europe(all income levels) in 2011?
Keep it short and to the point. 5.93. What is the difference between the Revenue generated (in %) of Euro area in 2009 and the Revenue generated (in %) of Estonia in 2011?
Your answer should be very brief. 13.44. What is the difference between the Revenue generated (in %) of Euro area in 2009 and the Revenue generated (in %) of Korea (Republic) in 2011?
Your answer should be very brief. -8.82. What is the difference between the Revenue generated (in %) of Europe(all income levels) in 2009 and the Revenue generated (in %) of Estonia in 2011?
Give a very brief answer. 7.86. What is the difference between the Revenue generated (in %) of Europe(all income levels) in 2009 and the Revenue generated (in %) of Korea (Republic) in 2011?
Your response must be concise. -14.41. What is the difference between the Revenue generated (in %) in Estonia in 2009 and the Revenue generated (in %) in Korea (Republic) in 2011?
Your answer should be very brief. -22.21. What is the difference between the Revenue generated (in %) of Euro area in 2010 and the Revenue generated (in %) of Europe(all income levels) in 2011?
Your answer should be compact. 5.24. What is the difference between the Revenue generated (in %) of Euro area in 2010 and the Revenue generated (in %) of Estonia in 2011?
Provide a succinct answer. 12.75. What is the difference between the Revenue generated (in %) of Euro area in 2010 and the Revenue generated (in %) of Korea (Republic) in 2011?
Ensure brevity in your answer.  -9.51. What is the difference between the Revenue generated (in %) of Europe(all income levels) in 2010 and the Revenue generated (in %) of Estonia in 2011?
Make the answer very short. 9.37. What is the difference between the Revenue generated (in %) of Europe(all income levels) in 2010 and the Revenue generated (in %) of Korea (Republic) in 2011?
Your answer should be very brief. -12.89. What is the difference between the Revenue generated (in %) of Estonia in 2010 and the Revenue generated (in %) of Korea (Republic) in 2011?
Your answer should be compact. -22.55. What is the average Revenue generated (in %) of Euro area per year?
Make the answer very short. 22.1. What is the average Revenue generated (in %) of Europe(all income levels) per year?
Provide a short and direct response. 17.3. What is the average Revenue generated (in %) in Estonia per year?
Your answer should be compact. 10.27. What is the average Revenue generated (in %) of Korea (Republic) per year?
Make the answer very short. 29.32. In the year 2004, what is the difference between the Revenue generated (in %) of Euro area and Revenue generated (in %) of Europe(all income levels)?
Provide a succinct answer. 4.05. In the year 2004, what is the difference between the Revenue generated (in %) in Euro area and Revenue generated (in %) in Estonia?
Keep it short and to the point. 7.5. In the year 2004, what is the difference between the Revenue generated (in %) in Euro area and Revenue generated (in %) in Korea (Republic)?
Make the answer very short. -5.94. In the year 2004, what is the difference between the Revenue generated (in %) of Europe(all income levels) and Revenue generated (in %) of Estonia?
Keep it short and to the point. 3.45. In the year 2004, what is the difference between the Revenue generated (in %) of Europe(all income levels) and Revenue generated (in %) of Korea (Republic)?
Offer a terse response. -9.99. In the year 2004, what is the difference between the Revenue generated (in %) in Estonia and Revenue generated (in %) in Korea (Republic)?
Offer a very short reply. -13.44. In the year 2005, what is the difference between the Revenue generated (in %) in Euro area and Revenue generated (in %) in Europe(all income levels)?
Provide a short and direct response. 3.38. In the year 2005, what is the difference between the Revenue generated (in %) of Euro area and Revenue generated (in %) of Estonia?
Give a very brief answer. 10.78. In the year 2005, what is the difference between the Revenue generated (in %) in Euro area and Revenue generated (in %) in Korea (Republic)?
Keep it short and to the point. -6.95. In the year 2005, what is the difference between the Revenue generated (in %) of Europe(all income levels) and Revenue generated (in %) of Estonia?
Your answer should be very brief. 7.4. In the year 2005, what is the difference between the Revenue generated (in %) of Europe(all income levels) and Revenue generated (in %) of Korea (Republic)?
Provide a short and direct response. -10.33. In the year 2005, what is the difference between the Revenue generated (in %) in Estonia and Revenue generated (in %) in Korea (Republic)?
Offer a very short reply. -17.74. In the year 2006, what is the difference between the Revenue generated (in %) of Euro area and Revenue generated (in %) of Europe(all income levels)?
Provide a short and direct response. 4.72. In the year 2006, what is the difference between the Revenue generated (in %) of Euro area and Revenue generated (in %) of Estonia?
Provide a succinct answer. 11.79. In the year 2006, what is the difference between the Revenue generated (in %) of Euro area and Revenue generated (in %) of Korea (Republic)?
Ensure brevity in your answer.  -6.69. In the year 2006, what is the difference between the Revenue generated (in %) in Europe(all income levels) and Revenue generated (in %) in Estonia?
Offer a terse response. 7.07. In the year 2006, what is the difference between the Revenue generated (in %) in Europe(all income levels) and Revenue generated (in %) in Korea (Republic)?
Your response must be concise. -11.41. In the year 2006, what is the difference between the Revenue generated (in %) in Estonia and Revenue generated (in %) in Korea (Republic)?
Provide a short and direct response. -18.49. In the year 2007, what is the difference between the Revenue generated (in %) of Euro area and Revenue generated (in %) of Europe(all income levels)?
Offer a terse response. 6.09. In the year 2007, what is the difference between the Revenue generated (in %) of Euro area and Revenue generated (in %) of Estonia?
Provide a succinct answer. 11.94. In the year 2007, what is the difference between the Revenue generated (in %) in Euro area and Revenue generated (in %) in Korea (Republic)?
Make the answer very short. -8.2. In the year 2007, what is the difference between the Revenue generated (in %) of Europe(all income levels) and Revenue generated (in %) of Estonia?
Your answer should be very brief. 5.86. In the year 2007, what is the difference between the Revenue generated (in %) in Europe(all income levels) and Revenue generated (in %) in Korea (Republic)?
Provide a succinct answer. -14.29. In the year 2007, what is the difference between the Revenue generated (in %) in Estonia and Revenue generated (in %) in Korea (Republic)?
Your response must be concise. -20.15. In the year 2008, what is the difference between the Revenue generated (in %) of Euro area and Revenue generated (in %) of Europe(all income levels)?
Provide a short and direct response. 5.14. In the year 2008, what is the difference between the Revenue generated (in %) of Euro area and Revenue generated (in %) of Estonia?
Your response must be concise. 12.67. In the year 2008, what is the difference between the Revenue generated (in %) in Euro area and Revenue generated (in %) in Korea (Republic)?
Ensure brevity in your answer.  -7.06. In the year 2008, what is the difference between the Revenue generated (in %) of Europe(all income levels) and Revenue generated (in %) of Estonia?
Provide a succinct answer. 7.53. In the year 2008, what is the difference between the Revenue generated (in %) in Europe(all income levels) and Revenue generated (in %) in Korea (Republic)?
Provide a succinct answer. -12.2. In the year 2008, what is the difference between the Revenue generated (in %) in Estonia and Revenue generated (in %) in Korea (Republic)?
Ensure brevity in your answer.  -19.73. In the year 2009, what is the difference between the Revenue generated (in %) in Euro area and Revenue generated (in %) in Europe(all income levels)?
Give a very brief answer. 5.58. In the year 2009, what is the difference between the Revenue generated (in %) of Euro area and Revenue generated (in %) of Estonia?
Your answer should be compact. 13.39. In the year 2009, what is the difference between the Revenue generated (in %) in Euro area and Revenue generated (in %) in Korea (Republic)?
Your answer should be very brief. -6.88. In the year 2009, what is the difference between the Revenue generated (in %) in Europe(all income levels) and Revenue generated (in %) in Estonia?
Your answer should be compact. 7.8. In the year 2009, what is the difference between the Revenue generated (in %) of Europe(all income levels) and Revenue generated (in %) of Korea (Republic)?
Your answer should be very brief. -12.46. In the year 2009, what is the difference between the Revenue generated (in %) in Estonia and Revenue generated (in %) in Korea (Republic)?
Provide a succinct answer. -20.27. In the year 2010, what is the difference between the Revenue generated (in %) in Euro area and Revenue generated (in %) in Europe(all income levels)?
Your response must be concise. 3.38. In the year 2010, what is the difference between the Revenue generated (in %) in Euro area and Revenue generated (in %) in Estonia?
Your answer should be compact. 13.04. In the year 2010, what is the difference between the Revenue generated (in %) in Euro area and Revenue generated (in %) in Korea (Republic)?
Your response must be concise. -7.3. In the year 2010, what is the difference between the Revenue generated (in %) in Europe(all income levels) and Revenue generated (in %) in Estonia?
Offer a terse response. 9.66. In the year 2010, what is the difference between the Revenue generated (in %) in Europe(all income levels) and Revenue generated (in %) in Korea (Republic)?
Your response must be concise. -10.68. In the year 2010, what is the difference between the Revenue generated (in %) in Estonia and Revenue generated (in %) in Korea (Republic)?
Provide a short and direct response. -20.34. In the year 2011, what is the difference between the Revenue generated (in %) of Euro area and Revenue generated (in %) of Europe(all income levels)?
Provide a succinct answer. 6.02. In the year 2011, what is the difference between the Revenue generated (in %) in Euro area and Revenue generated (in %) in Estonia?
Give a very brief answer. 13.53. In the year 2011, what is the difference between the Revenue generated (in %) of Euro area and Revenue generated (in %) of Korea (Republic)?
Provide a succinct answer. -8.73. In the year 2011, what is the difference between the Revenue generated (in %) of Europe(all income levels) and Revenue generated (in %) of Estonia?
Your response must be concise. 7.51. In the year 2011, what is the difference between the Revenue generated (in %) of Europe(all income levels) and Revenue generated (in %) of Korea (Republic)?
Offer a terse response. -14.75. In the year 2011, what is the difference between the Revenue generated (in %) in Estonia and Revenue generated (in %) in Korea (Republic)?
Ensure brevity in your answer.  -22.26. What is the ratio of the Revenue generated (in %) of Euro area in 2004 to that in 2005?
Your response must be concise. 0.98. What is the ratio of the Revenue generated (in %) in Europe(all income levels) in 2004 to that in 2005?
Your answer should be very brief. 0.94. What is the ratio of the Revenue generated (in %) of Estonia in 2004 to that in 2005?
Offer a very short reply. 1.26. What is the ratio of the Revenue generated (in %) in Korea (Republic) in 2004 to that in 2005?
Your response must be concise. 0.95. What is the ratio of the Revenue generated (in %) of Euro area in 2004 to that in 2006?
Make the answer very short. 0.95. What is the ratio of the Revenue generated (in %) in Europe(all income levels) in 2004 to that in 2006?
Your response must be concise. 0.98. What is the ratio of the Revenue generated (in %) of Estonia in 2004 to that in 2006?
Your response must be concise. 1.3. What is the ratio of the Revenue generated (in %) of Korea (Republic) in 2004 to that in 2006?
Your response must be concise. 0.94. What is the ratio of the Revenue generated (in %) of Euro area in 2004 to that in 2007?
Your answer should be compact. 0.92. What is the ratio of the Revenue generated (in %) in Europe(all income levels) in 2004 to that in 2007?
Provide a succinct answer. 1.02. What is the ratio of the Revenue generated (in %) of Estonia in 2004 to that in 2007?
Your answer should be very brief. 1.24. What is the ratio of the Revenue generated (in %) in Korea (Republic) in 2004 to that in 2007?
Provide a succinct answer. 0.87. What is the ratio of the Revenue generated (in %) of Euro area in 2004 to that in 2008?
Provide a short and direct response. 0.91. What is the ratio of the Revenue generated (in %) in Europe(all income levels) in 2004 to that in 2008?
Your response must be concise. 0.95. What is the ratio of the Revenue generated (in %) in Estonia in 2004 to that in 2008?
Keep it short and to the point. 1.29. What is the ratio of the Revenue generated (in %) of Korea (Republic) in 2004 to that in 2008?
Give a very brief answer. 0.9. What is the ratio of the Revenue generated (in %) of Europe(all income levels) in 2004 to that in 2009?
Ensure brevity in your answer.  1.1. What is the ratio of the Revenue generated (in %) of Estonia in 2004 to that in 2009?
Your response must be concise. 1.73. What is the ratio of the Revenue generated (in %) of Korea (Republic) in 2004 to that in 2009?
Provide a short and direct response. 0.97. What is the ratio of the Revenue generated (in %) of Euro area in 2004 to that in 2010?
Ensure brevity in your answer.  1.03. What is the ratio of the Revenue generated (in %) of Estonia in 2004 to that in 2010?
Keep it short and to the point. 1.8. What is the ratio of the Revenue generated (in %) in Korea (Republic) in 2004 to that in 2010?
Your response must be concise. 0.98. What is the ratio of the Revenue generated (in %) of Europe(all income levels) in 2004 to that in 2011?
Your response must be concise. 1.12. What is the ratio of the Revenue generated (in %) of Estonia in 2004 to that in 2011?
Keep it short and to the point. 1.74. What is the ratio of the Revenue generated (in %) of Korea (Republic) in 2004 to that in 2011?
Offer a terse response. 0.91. What is the ratio of the Revenue generated (in %) in Euro area in 2005 to that in 2006?
Your answer should be very brief. 0.97. What is the ratio of the Revenue generated (in %) in Europe(all income levels) in 2005 to that in 2006?
Provide a succinct answer. 1.04. What is the ratio of the Revenue generated (in %) in Estonia in 2005 to that in 2006?
Ensure brevity in your answer.  1.03. What is the ratio of the Revenue generated (in %) in Euro area in 2005 to that in 2007?
Make the answer very short. 0.94. What is the ratio of the Revenue generated (in %) in Europe(all income levels) in 2005 to that in 2007?
Your answer should be compact. 1.08. What is the ratio of the Revenue generated (in %) of Estonia in 2005 to that in 2007?
Keep it short and to the point. 0.98. What is the ratio of the Revenue generated (in %) of Korea (Republic) in 2005 to that in 2007?
Your response must be concise. 0.92. What is the ratio of the Revenue generated (in %) in Euro area in 2005 to that in 2008?
Keep it short and to the point. 0.93. What is the ratio of the Revenue generated (in %) in Europe(all income levels) in 2005 to that in 2008?
Provide a short and direct response. 1.01. What is the ratio of the Revenue generated (in %) of Estonia in 2005 to that in 2008?
Ensure brevity in your answer.  1.02. What is the ratio of the Revenue generated (in %) of Korea (Republic) in 2005 to that in 2008?
Provide a short and direct response. 0.94. What is the ratio of the Revenue generated (in %) of Euro area in 2005 to that in 2009?
Your response must be concise. 1.02. What is the ratio of the Revenue generated (in %) in Europe(all income levels) in 2005 to that in 2009?
Keep it short and to the point. 1.17. What is the ratio of the Revenue generated (in %) of Estonia in 2005 to that in 2009?
Your answer should be compact. 1.37. What is the ratio of the Revenue generated (in %) in Korea (Republic) in 2005 to that in 2009?
Make the answer very short. 1.02. What is the ratio of the Revenue generated (in %) in Euro area in 2005 to that in 2010?
Offer a very short reply. 1.05. What is the ratio of the Revenue generated (in %) of Europe(all income levels) in 2005 to that in 2010?
Your answer should be compact. 1.06. What is the ratio of the Revenue generated (in %) in Estonia in 2005 to that in 2010?
Provide a succinct answer. 1.43. What is the ratio of the Revenue generated (in %) of Korea (Republic) in 2005 to that in 2010?
Provide a short and direct response. 1.03. What is the ratio of the Revenue generated (in %) of Euro area in 2005 to that in 2011?
Provide a short and direct response. 1.02. What is the ratio of the Revenue generated (in %) of Europe(all income levels) in 2005 to that in 2011?
Provide a succinct answer. 1.19. What is the ratio of the Revenue generated (in %) of Estonia in 2005 to that in 2011?
Offer a terse response. 1.38. What is the ratio of the Revenue generated (in %) in Korea (Republic) in 2005 to that in 2011?
Provide a succinct answer. 0.95. What is the ratio of the Revenue generated (in %) in Euro area in 2006 to that in 2007?
Provide a succinct answer. 0.97. What is the ratio of the Revenue generated (in %) in Europe(all income levels) in 2006 to that in 2007?
Your answer should be very brief. 1.04. What is the ratio of the Revenue generated (in %) of Estonia in 2006 to that in 2007?
Your answer should be very brief. 0.95. What is the ratio of the Revenue generated (in %) in Korea (Republic) in 2006 to that in 2007?
Give a very brief answer. 0.93. What is the ratio of the Revenue generated (in %) of Euro area in 2006 to that in 2008?
Provide a succinct answer. 0.96. What is the ratio of the Revenue generated (in %) of Europe(all income levels) in 2006 to that in 2008?
Your answer should be compact. 0.97. What is the ratio of the Revenue generated (in %) of Estonia in 2006 to that in 2008?
Ensure brevity in your answer.  0.99. What is the ratio of the Revenue generated (in %) of Korea (Republic) in 2006 to that in 2008?
Provide a succinct answer. 0.96. What is the ratio of the Revenue generated (in %) in Euro area in 2006 to that in 2009?
Your response must be concise. 1.05. What is the ratio of the Revenue generated (in %) of Europe(all income levels) in 2006 to that in 2009?
Offer a very short reply. 1.12. What is the ratio of the Revenue generated (in %) in Estonia in 2006 to that in 2009?
Offer a terse response. 1.33. What is the ratio of the Revenue generated (in %) in Korea (Republic) in 2006 to that in 2009?
Ensure brevity in your answer.  1.03. What is the ratio of the Revenue generated (in %) in Euro area in 2006 to that in 2010?
Keep it short and to the point. 1.09. What is the ratio of the Revenue generated (in %) in Europe(all income levels) in 2006 to that in 2010?
Your answer should be compact. 1.03. What is the ratio of the Revenue generated (in %) of Estonia in 2006 to that in 2010?
Give a very brief answer. 1.39. What is the ratio of the Revenue generated (in %) of Korea (Republic) in 2006 to that in 2010?
Provide a short and direct response. 1.04. What is the ratio of the Revenue generated (in %) in Euro area in 2006 to that in 2011?
Provide a short and direct response. 1.05. What is the ratio of the Revenue generated (in %) in Europe(all income levels) in 2006 to that in 2011?
Your answer should be compact. 1.15. What is the ratio of the Revenue generated (in %) in Estonia in 2006 to that in 2011?
Provide a succinct answer. 1.34. What is the ratio of the Revenue generated (in %) in Korea (Republic) in 2006 to that in 2011?
Give a very brief answer. 0.97. What is the ratio of the Revenue generated (in %) in Euro area in 2007 to that in 2008?
Offer a terse response. 0.99. What is the ratio of the Revenue generated (in %) of Europe(all income levels) in 2007 to that in 2008?
Provide a short and direct response. 0.93. What is the ratio of the Revenue generated (in %) in Estonia in 2007 to that in 2008?
Keep it short and to the point. 1.04. What is the ratio of the Revenue generated (in %) of Korea (Republic) in 2007 to that in 2008?
Give a very brief answer. 1.03. What is the ratio of the Revenue generated (in %) in Euro area in 2007 to that in 2009?
Provide a short and direct response. 1.08. What is the ratio of the Revenue generated (in %) of Europe(all income levels) in 2007 to that in 2009?
Offer a terse response. 1.08. What is the ratio of the Revenue generated (in %) in Estonia in 2007 to that in 2009?
Your answer should be very brief. 1.4. What is the ratio of the Revenue generated (in %) of Korea (Republic) in 2007 to that in 2009?
Give a very brief answer. 1.11. What is the ratio of the Revenue generated (in %) in Euro area in 2007 to that in 2010?
Provide a succinct answer. 1.12. What is the ratio of the Revenue generated (in %) of Europe(all income levels) in 2007 to that in 2010?
Make the answer very short. 0.99. What is the ratio of the Revenue generated (in %) in Estonia in 2007 to that in 2010?
Ensure brevity in your answer.  1.46. What is the ratio of the Revenue generated (in %) of Korea (Republic) in 2007 to that in 2010?
Offer a terse response. 1.12. What is the ratio of the Revenue generated (in %) in Euro area in 2007 to that in 2011?
Ensure brevity in your answer.  1.08. What is the ratio of the Revenue generated (in %) of Europe(all income levels) in 2007 to that in 2011?
Make the answer very short. 1.1. What is the ratio of the Revenue generated (in %) of Estonia in 2007 to that in 2011?
Make the answer very short. 1.4. What is the ratio of the Revenue generated (in %) of Korea (Republic) in 2007 to that in 2011?
Ensure brevity in your answer.  1.04. What is the ratio of the Revenue generated (in %) of Euro area in 2008 to that in 2009?
Your answer should be very brief. 1.1. What is the ratio of the Revenue generated (in %) of Europe(all income levels) in 2008 to that in 2009?
Make the answer very short. 1.16. What is the ratio of the Revenue generated (in %) in Estonia in 2008 to that in 2009?
Your answer should be very brief. 1.34. What is the ratio of the Revenue generated (in %) of Korea (Republic) in 2008 to that in 2009?
Your answer should be compact. 1.08. What is the ratio of the Revenue generated (in %) in Euro area in 2008 to that in 2010?
Offer a very short reply. 1.13. What is the ratio of the Revenue generated (in %) in Europe(all income levels) in 2008 to that in 2010?
Offer a terse response. 1.06. What is the ratio of the Revenue generated (in %) in Estonia in 2008 to that in 2010?
Your answer should be compact. 1.4. What is the ratio of the Revenue generated (in %) in Korea (Republic) in 2008 to that in 2010?
Keep it short and to the point. 1.09. What is the ratio of the Revenue generated (in %) of Euro area in 2008 to that in 2011?
Give a very brief answer. 1.09. What is the ratio of the Revenue generated (in %) of Europe(all income levels) in 2008 to that in 2011?
Keep it short and to the point. 1.18. What is the ratio of the Revenue generated (in %) of Estonia in 2008 to that in 2011?
Provide a short and direct response. 1.35. What is the ratio of the Revenue generated (in %) in Korea (Republic) in 2008 to that in 2011?
Offer a very short reply. 1.01. What is the ratio of the Revenue generated (in %) of Euro area in 2009 to that in 2010?
Provide a succinct answer. 1.03. What is the ratio of the Revenue generated (in %) in Europe(all income levels) in 2009 to that in 2010?
Your answer should be compact. 0.91. What is the ratio of the Revenue generated (in %) of Estonia in 2009 to that in 2010?
Provide a short and direct response. 1.04. What is the ratio of the Revenue generated (in %) in Korea (Republic) in 2009 to that in 2010?
Offer a terse response. 1.01. What is the ratio of the Revenue generated (in %) of Euro area in 2009 to that in 2011?
Offer a very short reply. 1. What is the ratio of the Revenue generated (in %) in Europe(all income levels) in 2009 to that in 2011?
Your response must be concise. 1.02. What is the ratio of the Revenue generated (in %) of Estonia in 2009 to that in 2011?
Give a very brief answer. 1.01. What is the ratio of the Revenue generated (in %) in Korea (Republic) in 2009 to that in 2011?
Offer a very short reply. 0.94. What is the ratio of the Revenue generated (in %) in Euro area in 2010 to that in 2011?
Offer a very short reply. 0.96. What is the ratio of the Revenue generated (in %) in Europe(all income levels) in 2010 to that in 2011?
Give a very brief answer. 1.12. What is the ratio of the Revenue generated (in %) of Estonia in 2010 to that in 2011?
Your answer should be very brief. 0.96. What is the ratio of the Revenue generated (in %) in Korea (Republic) in 2010 to that in 2011?
Give a very brief answer. 0.93. What is the difference between the highest and the second highest Revenue generated (in %) in Euro area?
Provide a succinct answer. 0.29. What is the difference between the highest and the second highest Revenue generated (in %) of Europe(all income levels)?
Keep it short and to the point. 0.13. What is the difference between the highest and the second highest Revenue generated (in %) in Estonia?
Your answer should be very brief. 2.69. What is the difference between the highest and the second highest Revenue generated (in %) of Korea (Republic)?
Provide a succinct answer. 0.85. What is the difference between the highest and the lowest Revenue generated (in %) in Euro area?
Make the answer very short. 2.74. What is the difference between the highest and the lowest Revenue generated (in %) of Europe(all income levels)?
Keep it short and to the point. 2.98. What is the difference between the highest and the lowest Revenue generated (in %) in Estonia?
Your answer should be very brief. 6.24. What is the difference between the highest and the lowest Revenue generated (in %) of Korea (Republic)?
Give a very brief answer. 4.02. 